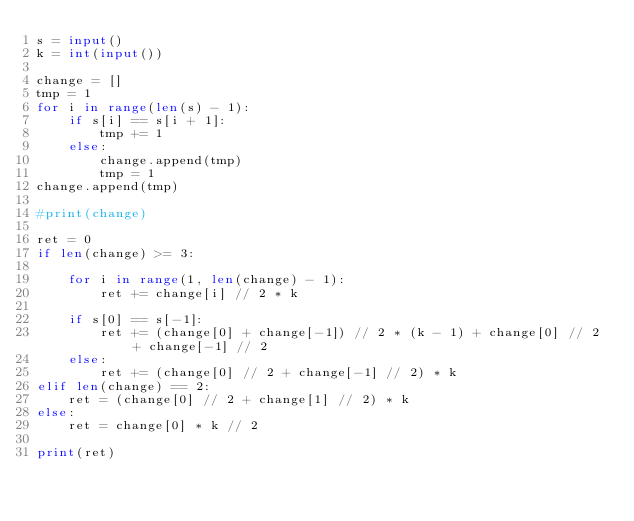Convert code to text. <code><loc_0><loc_0><loc_500><loc_500><_Python_>s = input()
k = int(input())

change = []
tmp = 1
for i in range(len(s) - 1):
    if s[i] == s[i + 1]:
        tmp += 1
    else:
        change.append(tmp)
        tmp = 1
change.append(tmp)

#print(change)

ret = 0
if len(change) >= 3:

    for i in range(1, len(change) - 1):
        ret += change[i] // 2 * k
    
    if s[0] == s[-1]:
        ret += (change[0] + change[-1]) // 2 * (k - 1) + change[0] // 2 + change[-1] // 2
    else:
        ret += (change[0] // 2 + change[-1] // 2) * k
elif len(change) == 2:
    ret = (change[0] // 2 + change[1] // 2) * k
else:
    ret = change[0] * k // 2

print(ret)</code> 